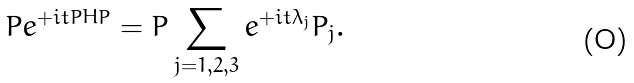<formula> <loc_0><loc_0><loc_500><loc_500>P e ^ { + i t P H P } = P \sum _ { j = 1 , 2 , 3 } e ^ { + i t { \lambda } _ { j } } P _ { j } .</formula> 